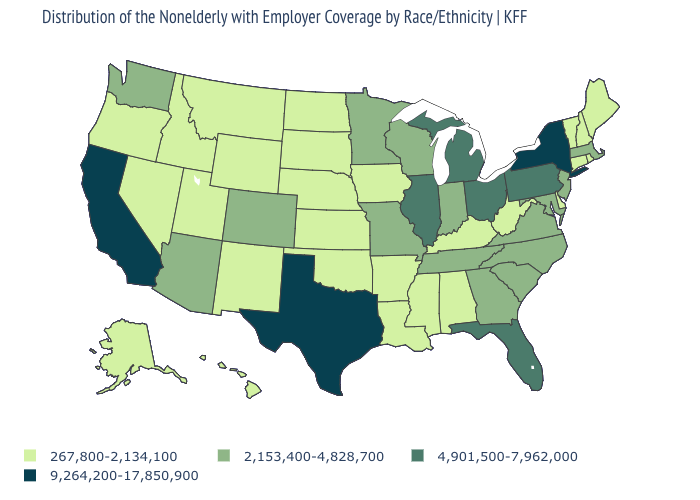Does North Dakota have the highest value in the MidWest?
Quick response, please. No. Which states hav the highest value in the Northeast?
Short answer required. New York. What is the lowest value in the USA?
Concise answer only. 267,800-2,134,100. Is the legend a continuous bar?
Write a very short answer. No. What is the value of Mississippi?
Concise answer only. 267,800-2,134,100. Name the states that have a value in the range 9,264,200-17,850,900?
Quick response, please. California, New York, Texas. What is the value of Alaska?
Short answer required. 267,800-2,134,100. Name the states that have a value in the range 2,153,400-4,828,700?
Short answer required. Arizona, Colorado, Georgia, Indiana, Maryland, Massachusetts, Minnesota, Missouri, New Jersey, North Carolina, South Carolina, Tennessee, Virginia, Washington, Wisconsin. What is the highest value in states that border Illinois?
Quick response, please. 2,153,400-4,828,700. Name the states that have a value in the range 4,901,500-7,962,000?
Be succinct. Florida, Illinois, Michigan, Ohio, Pennsylvania. Is the legend a continuous bar?
Answer briefly. No. What is the value of Connecticut?
Short answer required. 267,800-2,134,100. Does New York have the highest value in the USA?
Quick response, please. Yes. Among the states that border Delaware , does Maryland have the highest value?
Short answer required. No. Name the states that have a value in the range 4,901,500-7,962,000?
Short answer required. Florida, Illinois, Michigan, Ohio, Pennsylvania. 